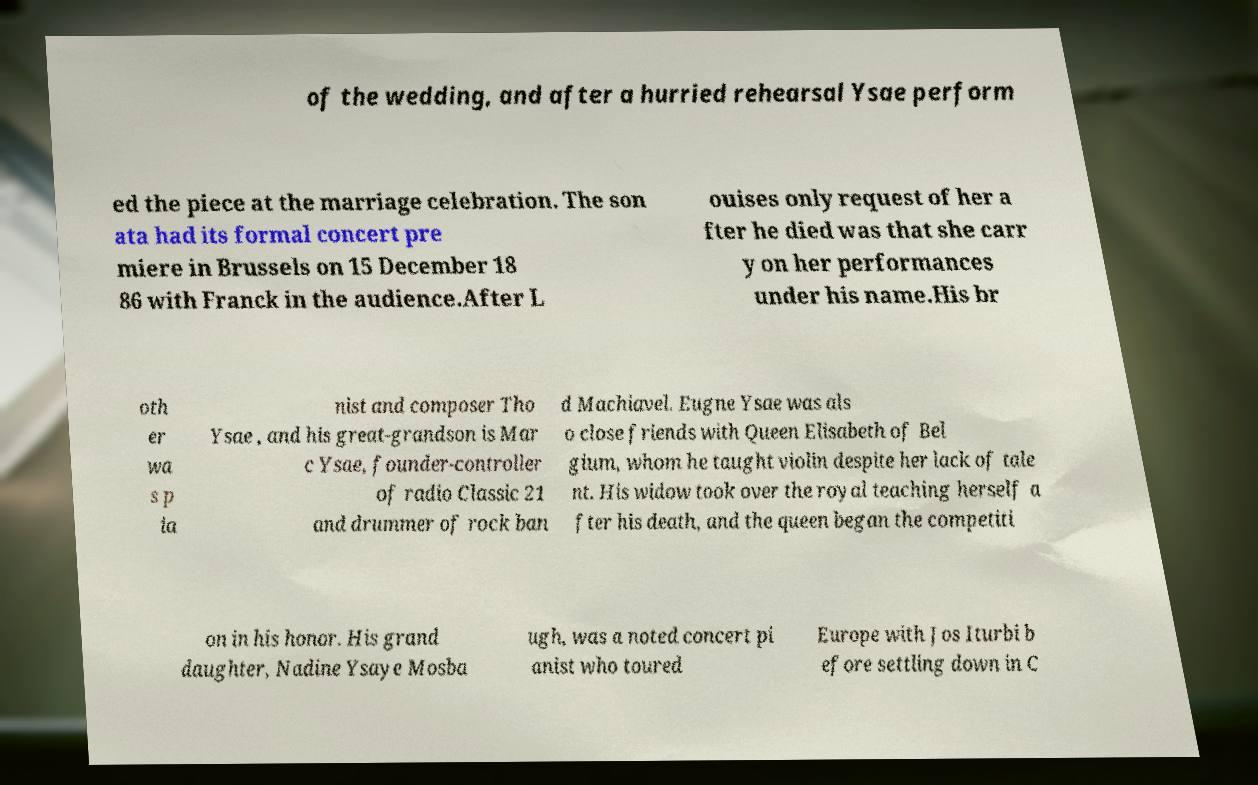Please read and relay the text visible in this image. What does it say? of the wedding, and after a hurried rehearsal Ysae perform ed the piece at the marriage celebration. The son ata had its formal concert pre miere in Brussels on 15 December 18 86 with Franck in the audience.After L ouises only request of her a fter he died was that she carr y on her performances under his name.His br oth er wa s p ia nist and composer Tho Ysae , and his great-grandson is Mar c Ysae, founder-controller of radio Classic 21 and drummer of rock ban d Machiavel. Eugne Ysae was als o close friends with Queen Elisabeth of Bel gium, whom he taught violin despite her lack of tale nt. His widow took over the royal teaching herself a fter his death, and the queen began the competiti on in his honor. His grand daughter, Nadine Ysaye Mosba ugh, was a noted concert pi anist who toured Europe with Jos Iturbi b efore settling down in C 